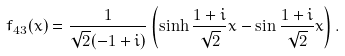Convert formula to latex. <formula><loc_0><loc_0><loc_500><loc_500>f _ { 4 3 } ( x ) = \frac { 1 } { \sqrt { 2 } ( - 1 + i ) } \left ( \sinh \frac { 1 + i } { \sqrt { 2 } } x - \sin \frac { 1 + i } { \sqrt { 2 } } x \right ) .</formula> 